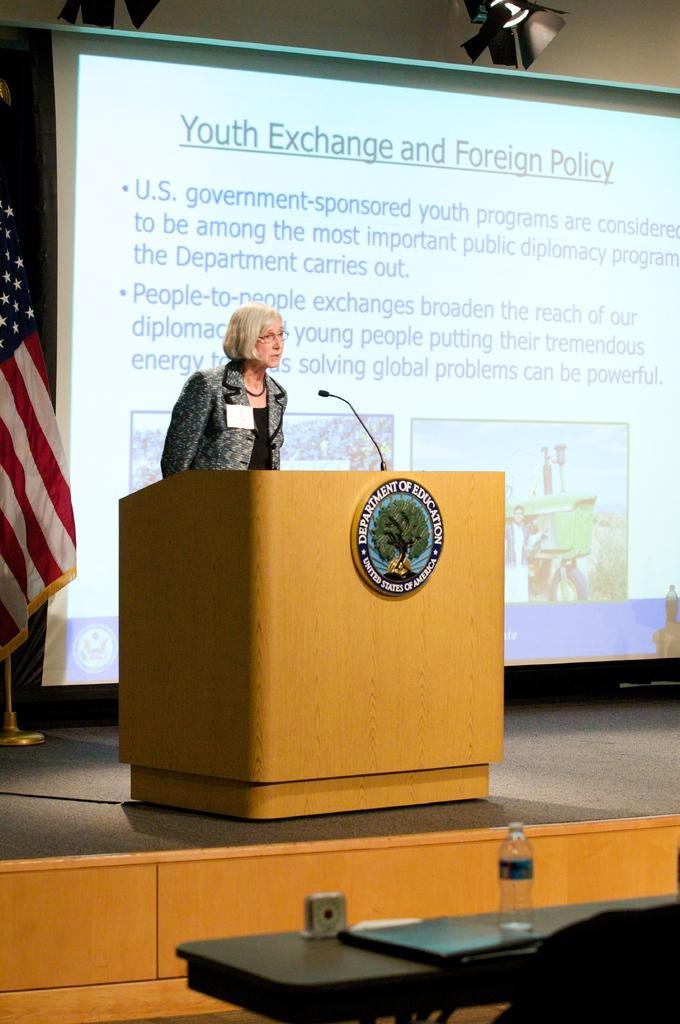Can you describe this image briefly? In this image we can see a lady standing behind a podium which consists of a microphone and a logo on it, behind her there is a screen on which some text and images are projected, on the left side of the image we can see a flag, at the bottom of the image there is a table which contains water bottle and some objects, on the top of the image there is a light. 